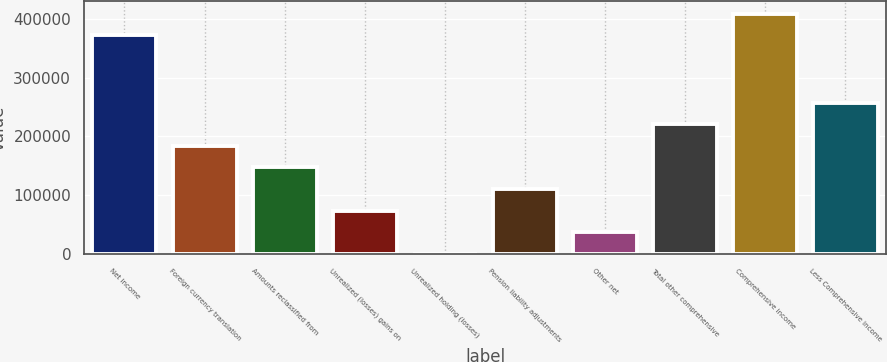Convert chart to OTSL. <chart><loc_0><loc_0><loc_500><loc_500><bar_chart><fcel>Net income<fcel>Foreign currency translation<fcel>Amounts reclassified from<fcel>Unrealized (losses) gains on<fcel>Unrealized holding (losses)<fcel>Pension liability adjustments<fcel>Other net<fcel>Total other comprehensive<fcel>Comprehensive income<fcel>Less Comprehensive income<nl><fcel>372037<fcel>184040<fcel>147463<fcel>74306.8<fcel>1151<fcel>110885<fcel>37728.9<fcel>220618<fcel>408615<fcel>257196<nl></chart> 